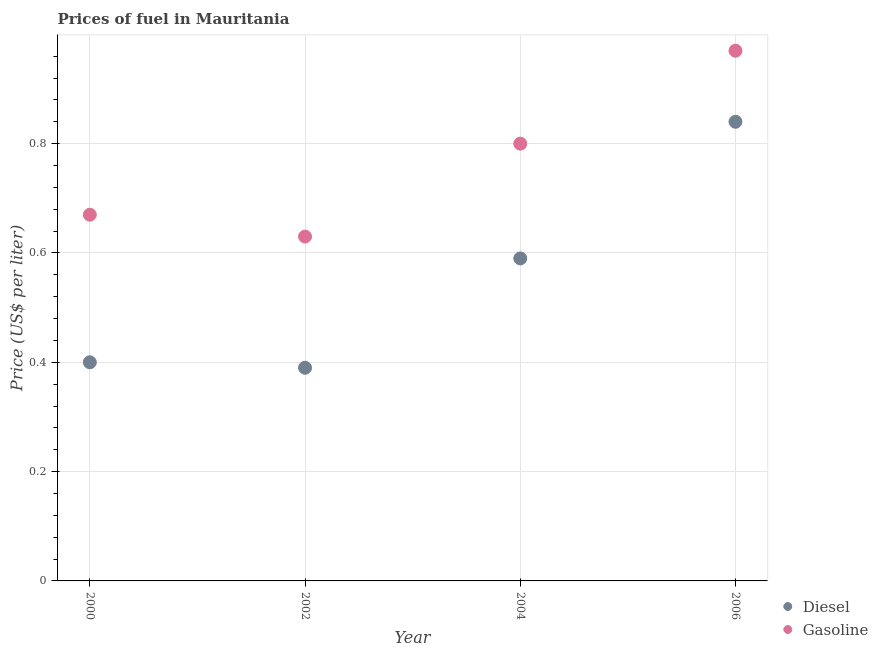What is the diesel price in 2002?
Offer a terse response. 0.39. Across all years, what is the maximum gasoline price?
Give a very brief answer. 0.97. Across all years, what is the minimum diesel price?
Offer a very short reply. 0.39. In which year was the diesel price maximum?
Give a very brief answer. 2006. What is the total gasoline price in the graph?
Ensure brevity in your answer.  3.07. What is the difference between the diesel price in 2000 and that in 2006?
Keep it short and to the point. -0.44. What is the difference between the diesel price in 2000 and the gasoline price in 2004?
Your response must be concise. -0.4. What is the average diesel price per year?
Your response must be concise. 0.55. In the year 2002, what is the difference between the diesel price and gasoline price?
Make the answer very short. -0.24. What is the ratio of the diesel price in 2000 to that in 2006?
Offer a terse response. 0.48. Is the difference between the gasoline price in 2004 and 2006 greater than the difference between the diesel price in 2004 and 2006?
Make the answer very short. Yes. What is the difference between the highest and the lowest diesel price?
Keep it short and to the point. 0.45. In how many years, is the gasoline price greater than the average gasoline price taken over all years?
Provide a succinct answer. 2. Is the sum of the diesel price in 2002 and 2004 greater than the maximum gasoline price across all years?
Keep it short and to the point. Yes. Does the diesel price monotonically increase over the years?
Provide a succinct answer. No. Is the gasoline price strictly greater than the diesel price over the years?
Your response must be concise. Yes. What is the difference between two consecutive major ticks on the Y-axis?
Ensure brevity in your answer.  0.2. Where does the legend appear in the graph?
Keep it short and to the point. Bottom right. How many legend labels are there?
Ensure brevity in your answer.  2. How are the legend labels stacked?
Your answer should be compact. Vertical. What is the title of the graph?
Provide a succinct answer. Prices of fuel in Mauritania. What is the label or title of the Y-axis?
Keep it short and to the point. Price (US$ per liter). What is the Price (US$ per liter) in Gasoline in 2000?
Give a very brief answer. 0.67. What is the Price (US$ per liter) of Diesel in 2002?
Provide a succinct answer. 0.39. What is the Price (US$ per liter) of Gasoline in 2002?
Your answer should be compact. 0.63. What is the Price (US$ per liter) in Diesel in 2004?
Make the answer very short. 0.59. What is the Price (US$ per liter) of Gasoline in 2004?
Ensure brevity in your answer.  0.8. What is the Price (US$ per liter) of Diesel in 2006?
Your answer should be compact. 0.84. Across all years, what is the maximum Price (US$ per liter) of Diesel?
Your answer should be very brief. 0.84. Across all years, what is the maximum Price (US$ per liter) in Gasoline?
Make the answer very short. 0.97. Across all years, what is the minimum Price (US$ per liter) in Diesel?
Offer a very short reply. 0.39. Across all years, what is the minimum Price (US$ per liter) of Gasoline?
Provide a succinct answer. 0.63. What is the total Price (US$ per liter) in Diesel in the graph?
Ensure brevity in your answer.  2.22. What is the total Price (US$ per liter) in Gasoline in the graph?
Provide a succinct answer. 3.07. What is the difference between the Price (US$ per liter) in Diesel in 2000 and that in 2002?
Your answer should be very brief. 0.01. What is the difference between the Price (US$ per liter) in Gasoline in 2000 and that in 2002?
Give a very brief answer. 0.04. What is the difference between the Price (US$ per liter) of Diesel in 2000 and that in 2004?
Your response must be concise. -0.19. What is the difference between the Price (US$ per liter) of Gasoline in 2000 and that in 2004?
Provide a short and direct response. -0.13. What is the difference between the Price (US$ per liter) of Diesel in 2000 and that in 2006?
Offer a very short reply. -0.44. What is the difference between the Price (US$ per liter) of Gasoline in 2000 and that in 2006?
Provide a succinct answer. -0.3. What is the difference between the Price (US$ per liter) in Diesel in 2002 and that in 2004?
Your response must be concise. -0.2. What is the difference between the Price (US$ per liter) in Gasoline in 2002 and that in 2004?
Provide a short and direct response. -0.17. What is the difference between the Price (US$ per liter) of Diesel in 2002 and that in 2006?
Keep it short and to the point. -0.45. What is the difference between the Price (US$ per liter) of Gasoline in 2002 and that in 2006?
Your response must be concise. -0.34. What is the difference between the Price (US$ per liter) in Gasoline in 2004 and that in 2006?
Offer a terse response. -0.17. What is the difference between the Price (US$ per liter) of Diesel in 2000 and the Price (US$ per liter) of Gasoline in 2002?
Keep it short and to the point. -0.23. What is the difference between the Price (US$ per liter) in Diesel in 2000 and the Price (US$ per liter) in Gasoline in 2006?
Give a very brief answer. -0.57. What is the difference between the Price (US$ per liter) in Diesel in 2002 and the Price (US$ per liter) in Gasoline in 2004?
Offer a very short reply. -0.41. What is the difference between the Price (US$ per liter) in Diesel in 2002 and the Price (US$ per liter) in Gasoline in 2006?
Your answer should be very brief. -0.58. What is the difference between the Price (US$ per liter) of Diesel in 2004 and the Price (US$ per liter) of Gasoline in 2006?
Offer a terse response. -0.38. What is the average Price (US$ per liter) of Diesel per year?
Offer a very short reply. 0.56. What is the average Price (US$ per liter) in Gasoline per year?
Provide a short and direct response. 0.77. In the year 2000, what is the difference between the Price (US$ per liter) in Diesel and Price (US$ per liter) in Gasoline?
Your answer should be compact. -0.27. In the year 2002, what is the difference between the Price (US$ per liter) in Diesel and Price (US$ per liter) in Gasoline?
Provide a short and direct response. -0.24. In the year 2004, what is the difference between the Price (US$ per liter) of Diesel and Price (US$ per liter) of Gasoline?
Your answer should be compact. -0.21. In the year 2006, what is the difference between the Price (US$ per liter) in Diesel and Price (US$ per liter) in Gasoline?
Make the answer very short. -0.13. What is the ratio of the Price (US$ per liter) in Diesel in 2000 to that in 2002?
Give a very brief answer. 1.03. What is the ratio of the Price (US$ per liter) in Gasoline in 2000 to that in 2002?
Keep it short and to the point. 1.06. What is the ratio of the Price (US$ per liter) in Diesel in 2000 to that in 2004?
Keep it short and to the point. 0.68. What is the ratio of the Price (US$ per liter) of Gasoline in 2000 to that in 2004?
Provide a succinct answer. 0.84. What is the ratio of the Price (US$ per liter) of Diesel in 2000 to that in 2006?
Your response must be concise. 0.48. What is the ratio of the Price (US$ per liter) in Gasoline in 2000 to that in 2006?
Your answer should be compact. 0.69. What is the ratio of the Price (US$ per liter) in Diesel in 2002 to that in 2004?
Your response must be concise. 0.66. What is the ratio of the Price (US$ per liter) of Gasoline in 2002 to that in 2004?
Your answer should be compact. 0.79. What is the ratio of the Price (US$ per liter) in Diesel in 2002 to that in 2006?
Provide a succinct answer. 0.46. What is the ratio of the Price (US$ per liter) in Gasoline in 2002 to that in 2006?
Ensure brevity in your answer.  0.65. What is the ratio of the Price (US$ per liter) in Diesel in 2004 to that in 2006?
Keep it short and to the point. 0.7. What is the ratio of the Price (US$ per liter) of Gasoline in 2004 to that in 2006?
Provide a succinct answer. 0.82. What is the difference between the highest and the second highest Price (US$ per liter) of Gasoline?
Keep it short and to the point. 0.17. What is the difference between the highest and the lowest Price (US$ per liter) in Diesel?
Provide a short and direct response. 0.45. What is the difference between the highest and the lowest Price (US$ per liter) of Gasoline?
Give a very brief answer. 0.34. 